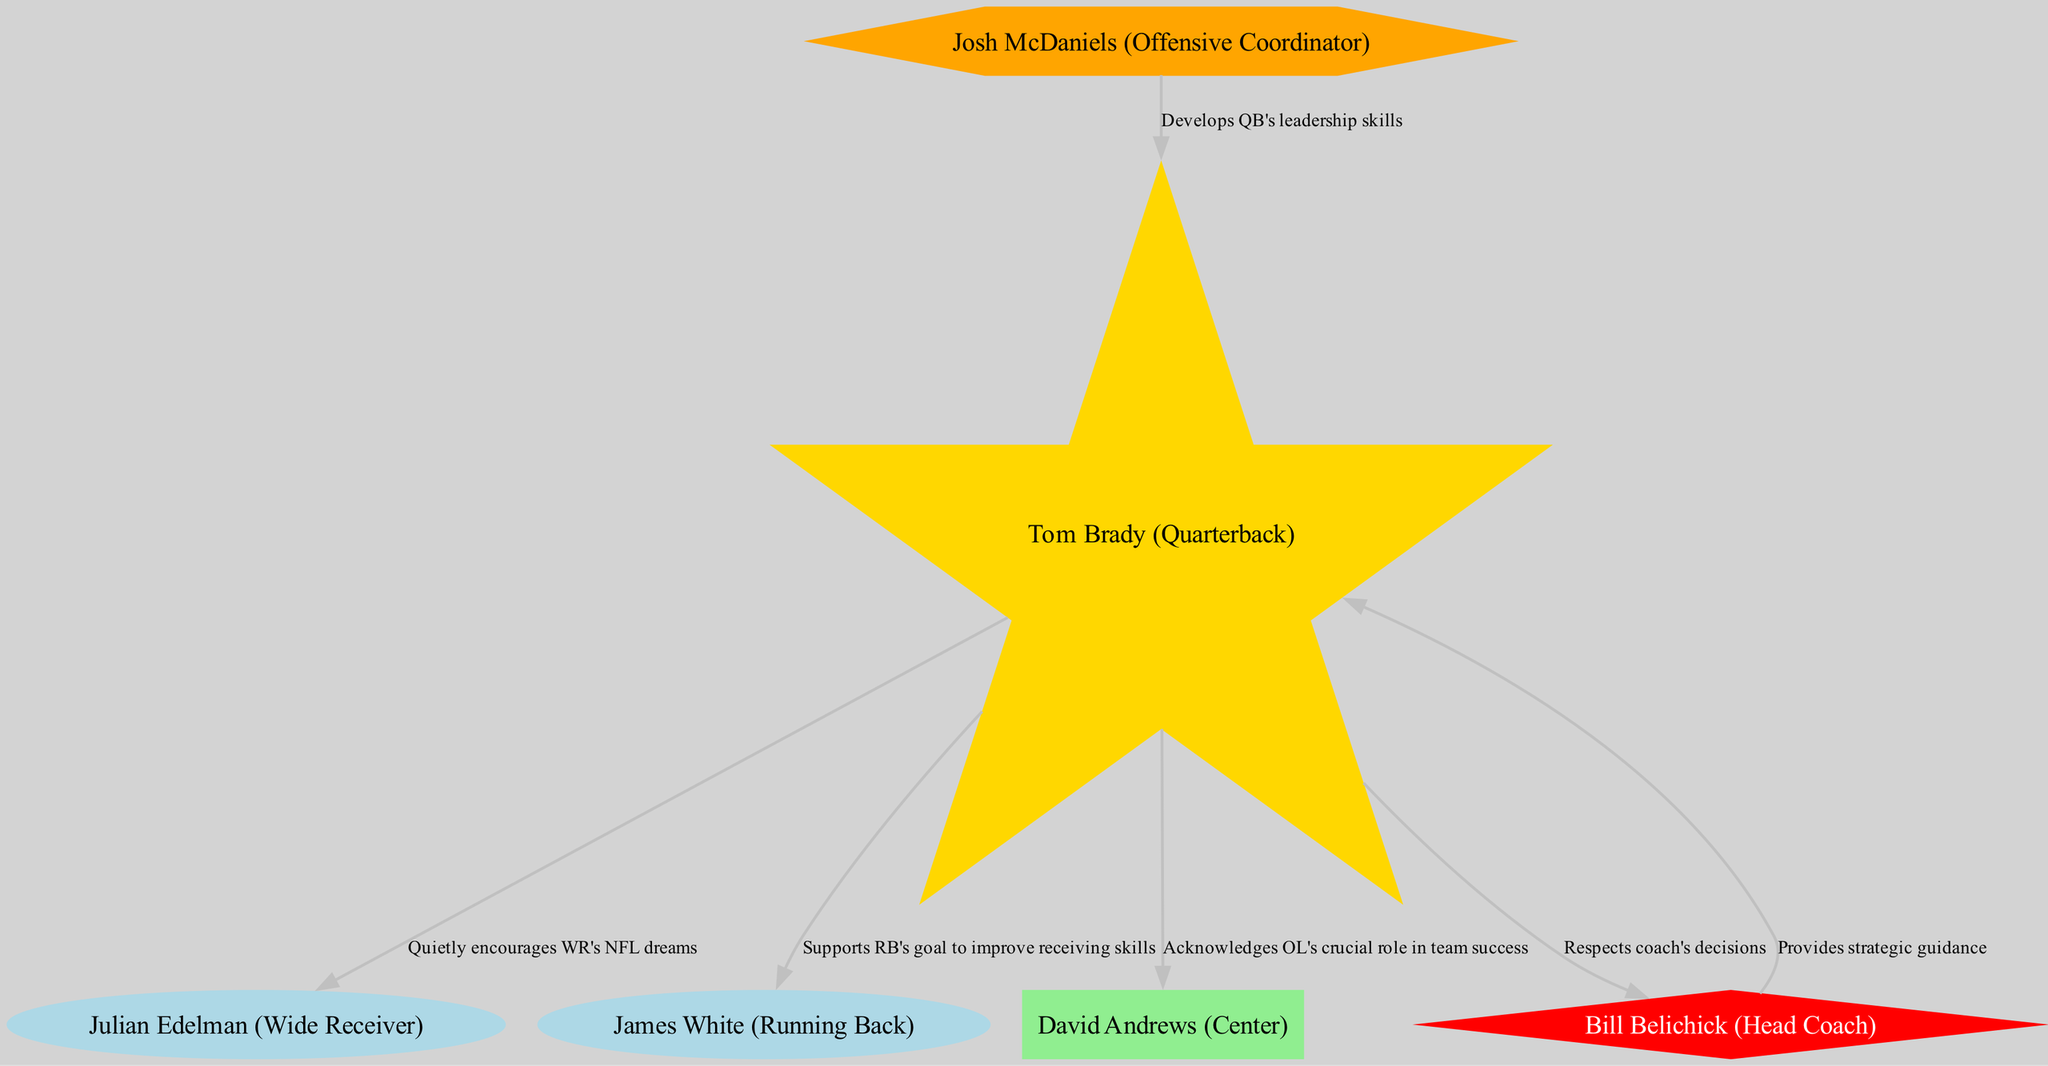What's the total number of nodes in the diagram? In the provided data, there are 6 nodes listed under the "nodes" key, which represent different team members and roles. Counting each one, we confirm the total number is 6.
Answer: 6 Which player is identified as the central player? The central player is defined in the node attributes. Scanning through the nodes, we find "Tom Brady (Quarterback)" marked as the central player, highlighting his key role in the team dynamics.
Answer: Tom Brady (Quarterback) How many key players are in the diagram? By examining the nodes, we look for the players classified as "Key Player." There are two listed: "Julian Edelman (Wide Receiver)" and "James White (Running Back)," therefore the count is 2.
Answer: 2 What relationship does the Quarterback have with the Offensive Coordinator? Referring to the edges, we see a directed edge from "QB" (Tom Brady) to "Mentor" (Josh McDaniels). The relationship is labeled as "Develops QB's leadership skills," indicating a supportive mentoring role by the Offensive Coordinator towards the Quarterback.
Answer: Develops QB's leadership skills What color represents the leadership role in the diagram? To determine the visual representation of leadership, we examine the node styles. The "Leadership" nodes are depicted using the color red, distinguishing them from other roles in the diagram.
Answer: Red What is the connection between the Quarterback and the Head Coach? Looking at the edges, there's a direct link from "QB" to "Coach." The relationship indicates "Respects coach's decisions," showing a respectful and collaborative connection between the Quarterback and the Head Coach.
Answer: Respects coach's decisions Which node acknowledges the role of the Center? We check the edges for interactions involving “OL” (David Andrews, Center). The Quarterback has an edge leading to the Center labeled as "Acknowledges OL's crucial role in team success," which highlights recognition of the Center's contributions.
Answer: Acknowledges OL's crucial role in team success What type of player is David Andrews categorized as? Checking the node data for David Andrews, we see he is marked with the type "Support Player." This classification indicates his role as a supportive team member rather than a key player or central player.
Answer: Support Player Who provides strategic guidance to the Quarterback? The edges clarify that "Coach" (Bill Belichick) has a directed relationship with the Quarterback indicating "Provides strategic guidance." Thus, the Head Coach plays a pivotal role in the Quarterback's strategic development.
Answer: Provides strategic guidance 